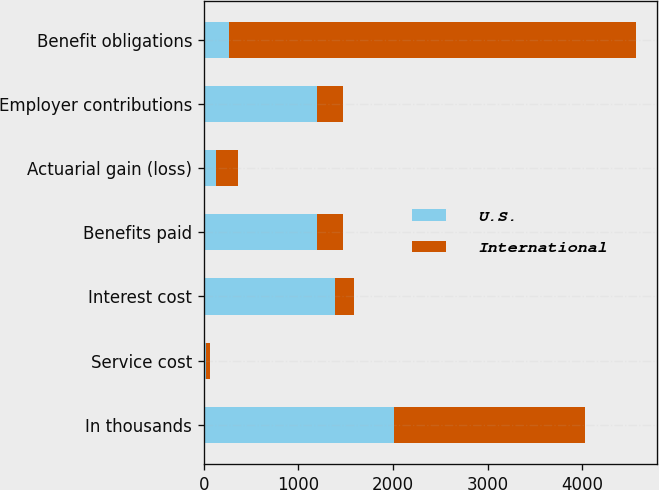Convert chart. <chart><loc_0><loc_0><loc_500><loc_500><stacked_bar_chart><ecel><fcel>In thousands<fcel>Service cost<fcel>Interest cost<fcel>Benefits paid<fcel>Actuarial gain (loss)<fcel>Employer contributions<fcel>Benefit obligations<nl><fcel>U.S.<fcel>2012<fcel>24<fcel>1387<fcel>1197<fcel>129<fcel>1197<fcel>270<nl><fcel>International<fcel>2012<fcel>45<fcel>201<fcel>270<fcel>228<fcel>270<fcel>4296<nl></chart> 